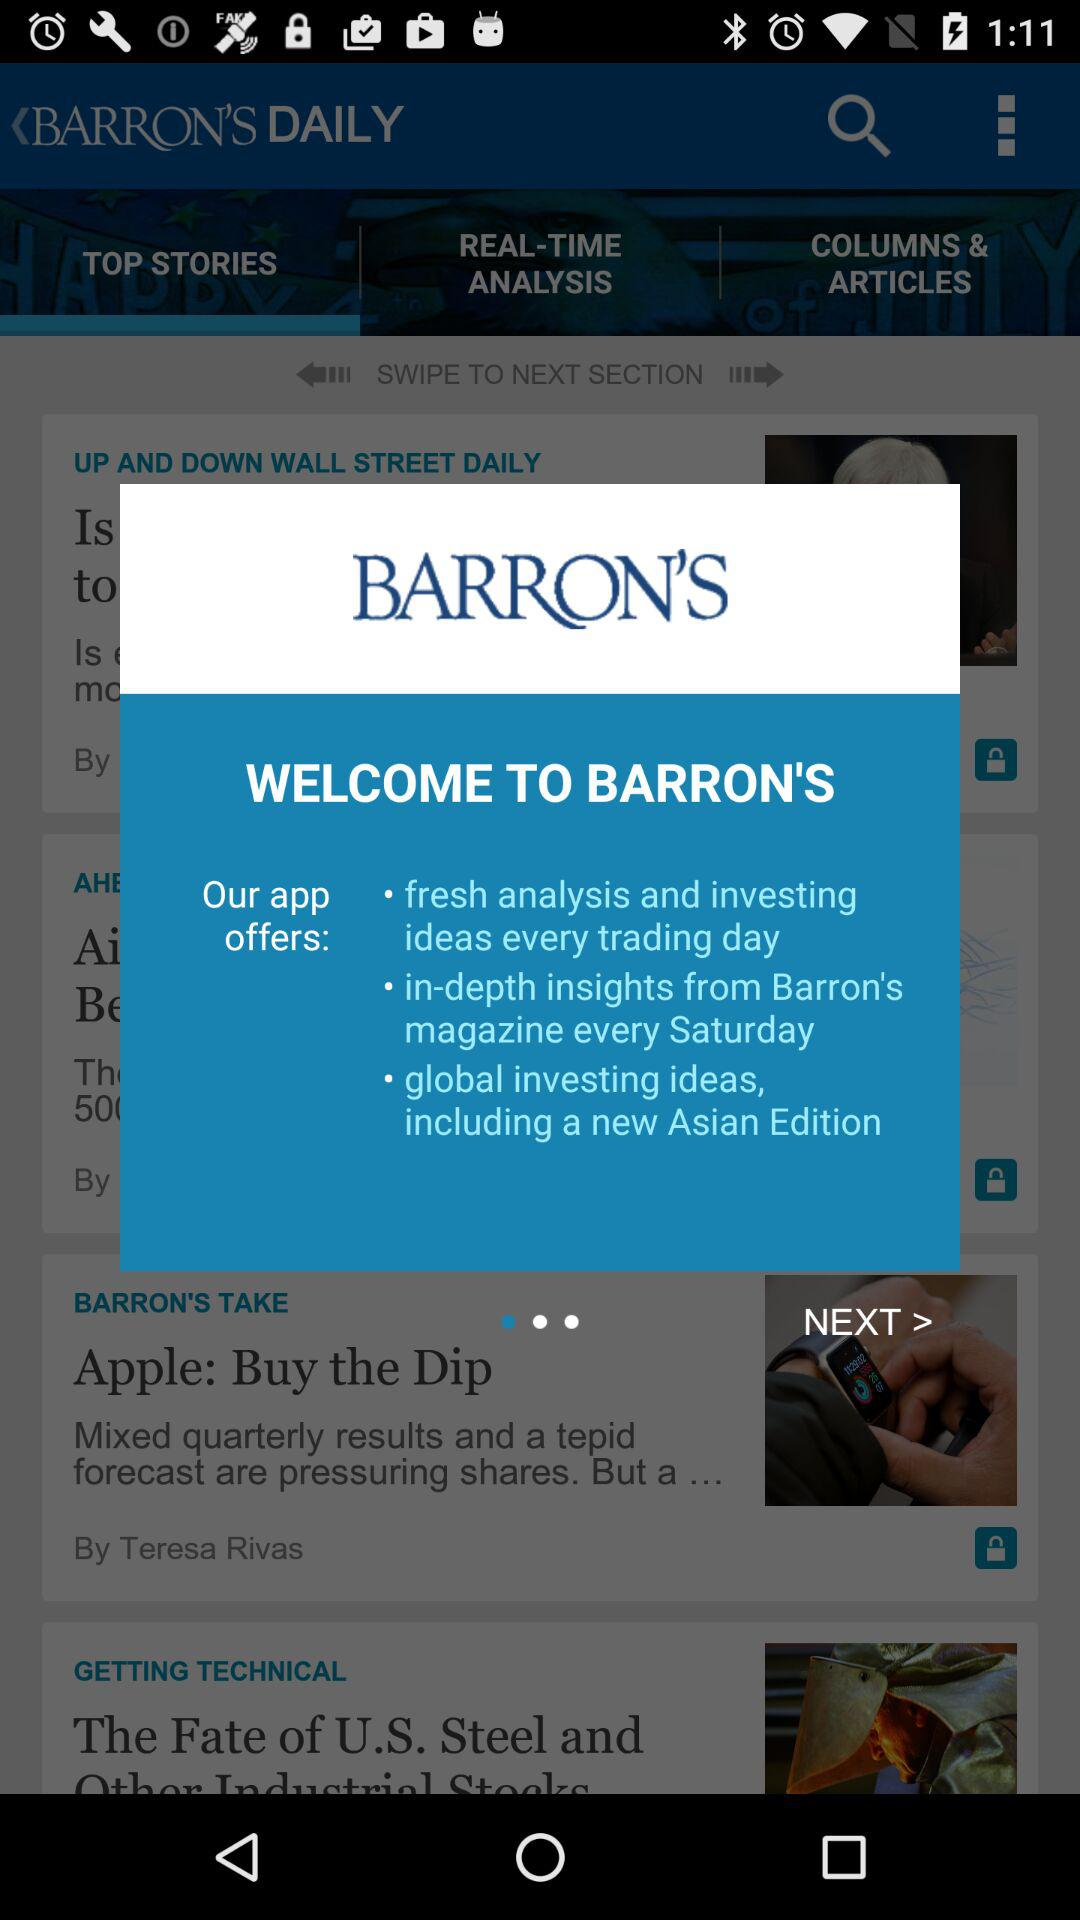What is the application name? The application name is "BARRON'S". 